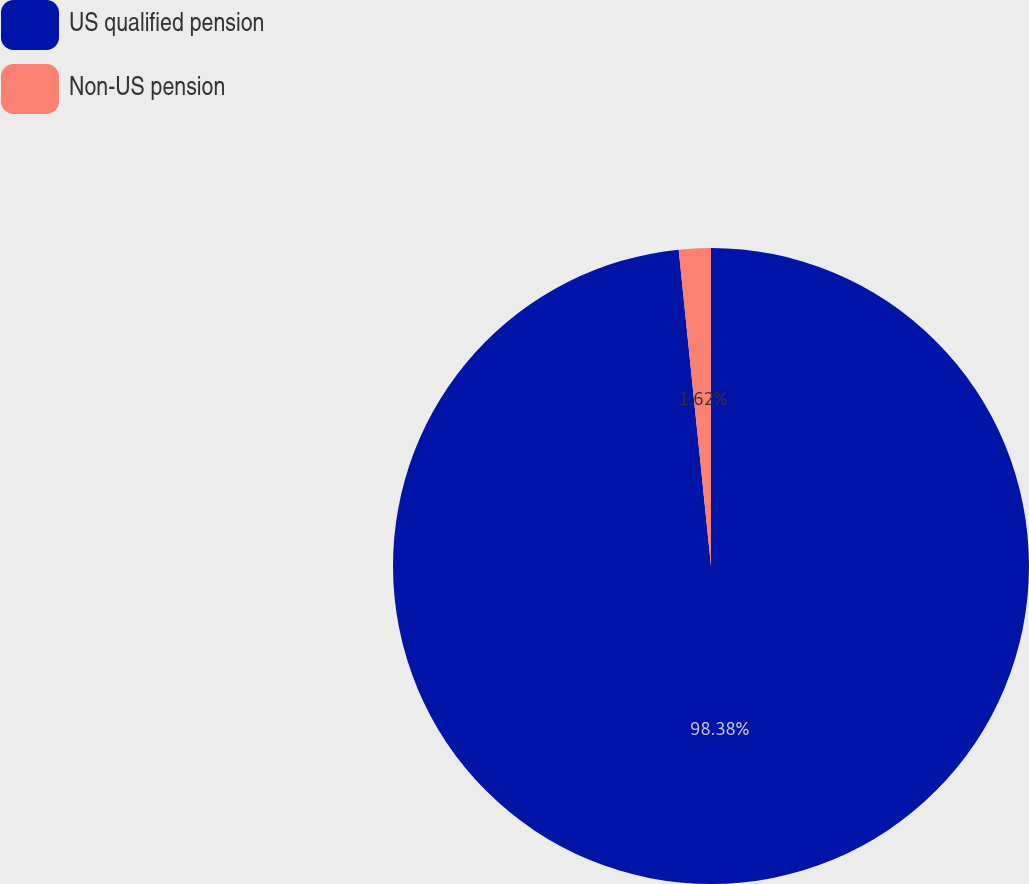<chart> <loc_0><loc_0><loc_500><loc_500><pie_chart><fcel>US qualified pension<fcel>Non-US pension<nl><fcel>98.38%<fcel>1.62%<nl></chart> 